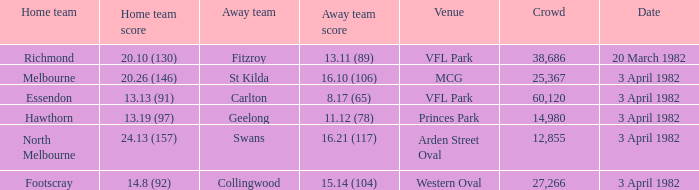Which home team played the away team of collingwood? Footscray. 